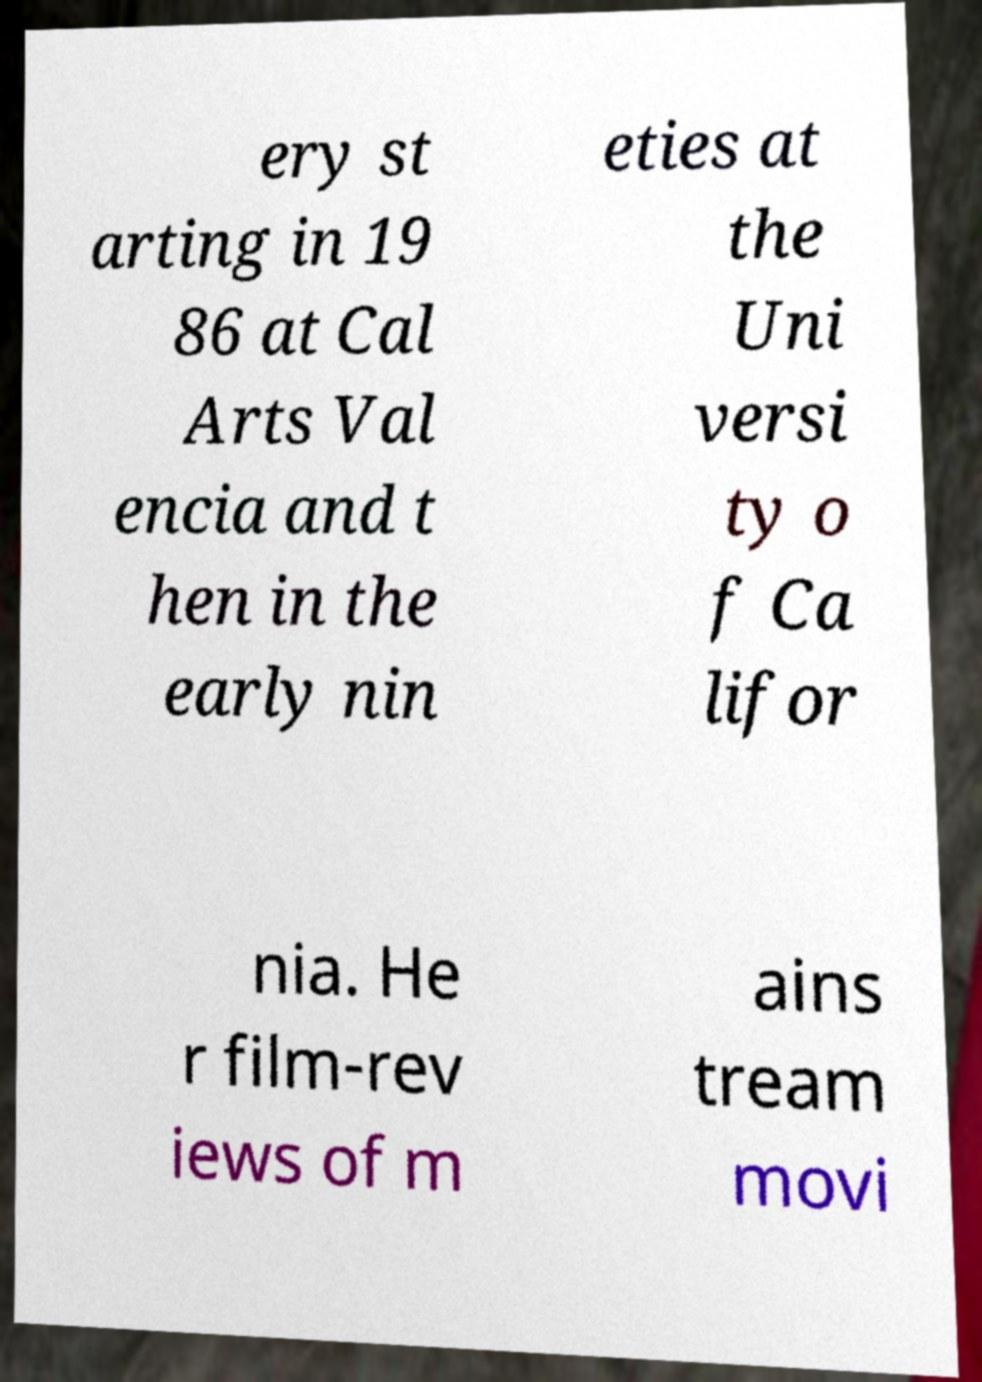There's text embedded in this image that I need extracted. Can you transcribe it verbatim? ery st arting in 19 86 at Cal Arts Val encia and t hen in the early nin eties at the Uni versi ty o f Ca lifor nia. He r film-rev iews of m ains tream movi 